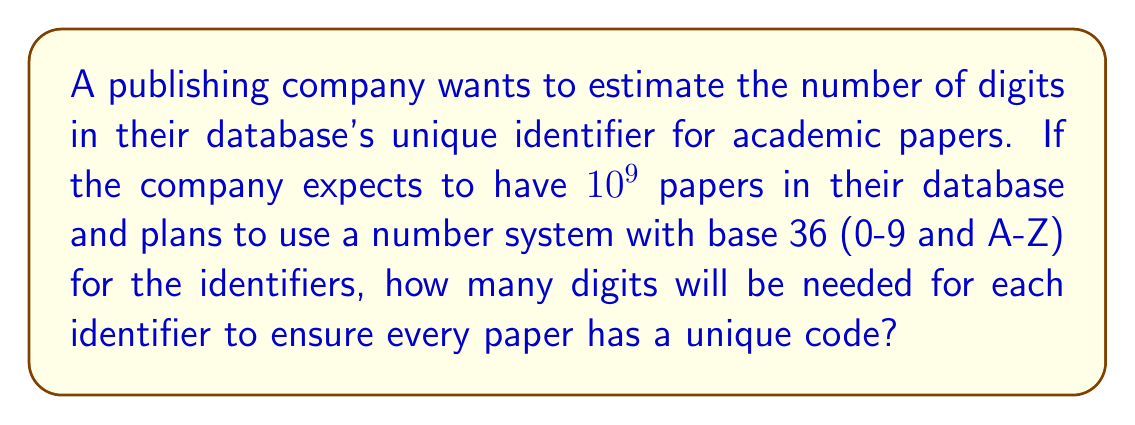Solve this math problem. To solve this problem, we'll use logarithms to determine the number of digits needed. Here's the step-by-step approach:

1) The number of papers is $10^9$.

2) We need to find $n$ such that $36^n \geq 10^9$, where $n$ is the number of digits in base 36.

3) Taking the logarithm of both sides with base 36:

   $\log_{36}(36^n) \geq \log_{36}(10^9)$

4) Simplify the left side using the logarithm property $\log_a(a^x) = x$:

   $n \geq \log_{36}(10^9)$

5) We can change the base of the logarithm using the change of base formula:

   $n \geq \frac{\log(10^9)}{\log(36)}$

6) Simplify:

   $n \geq \frac{9\log(10)}{\log(36)}$

7) Calculate this value:

   $n \geq 5.7546...$

8) Since $n$ must be an integer and we need to ensure we have enough digits for all papers, we round up to the next whole number.

Therefore, the company needs 6 digits for each identifier in base 36.
Answer: 6 digits 